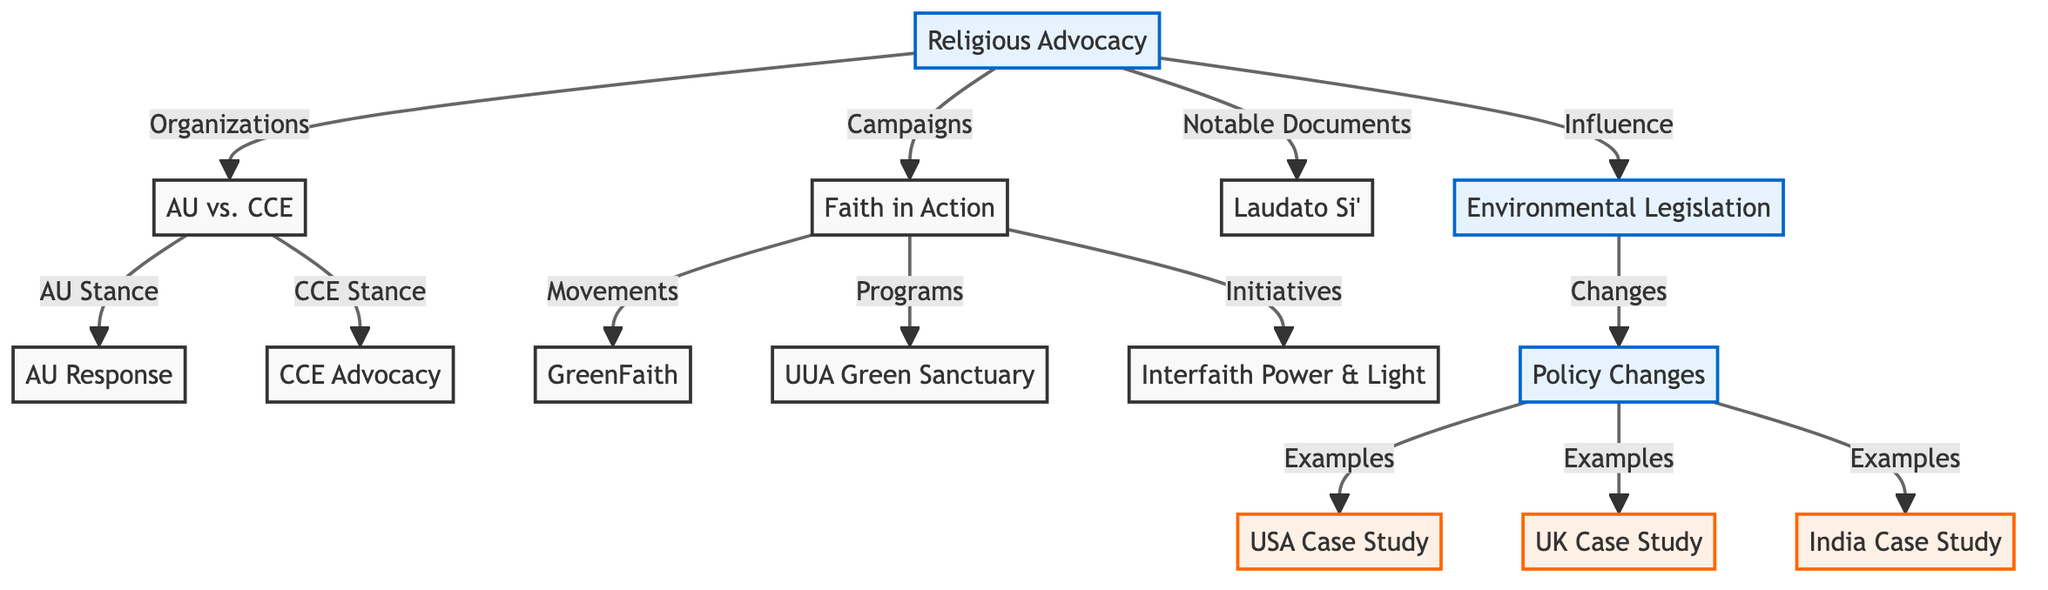What is the main subject of the diagram? The diagram is centered around the concept of "The Impact of Religious Advocacy on Environmental Legislation," which is explicitly stated in the title and connects to multiple themes and case studies throughout the visual.
Answer: The Impact of Religious Advocacy on Environmental Legislation How many case studies are mentioned in the diagram? There are three case studies identified in the diagram, labeled as "USA Case Study," "UK Case Study," and "India Case Study." These are the only nodes classified under case studies.
Answer: 3 Which node represents notable documents related to religious advocacy? The node marked "Laudato Si'" is specifically categorized as a notable document related to religious advocacy, indicating its significance within the broader discussion on environmental issues.
Answer: Laudato Si' What type of relationship exists between "Religious Advocacy" and "Environmental Legislation"? The relationship is described by the label "Influence," which suggests that religious advocacy has a direct impact on the formation and implementation of environmental legislation in various contexts.
Answer: Influence What is the focus of the "Faith in Action" node? The "Faith in Action" node encompasses several campaigns, movements, programs, and initiatives, highlighting its broader objective to mobilize religious communities in advocacy for environmental issues.
Answer: Campaigns Which advocacy organization is involved in the "American United for Separation of Church and State vs. Citizens' Campaign for the Environment" case? The case references "AU," which stands for American United for Separation of Church and State, indicating their involvement in this legal context regarding environmental advocacy.
Answer: AU What do the arrows leading from "Policy Changes" indicate? The arrows from "Policy Changes" leading to each case study signify that these policy changes serve as examples or manifestations of how religious advocacy has influenced environmental legislation in specific geographical contexts.
Answer: Examples What type of movement is affiliated with "Faith in Action"? The "GreenFaith" movement is mentioned as a specific movement that derives from or is associated with the "Faith in Action" campaigns, illustrating how religious groups advocate for environmental causes.
Answer: GreenFaith 